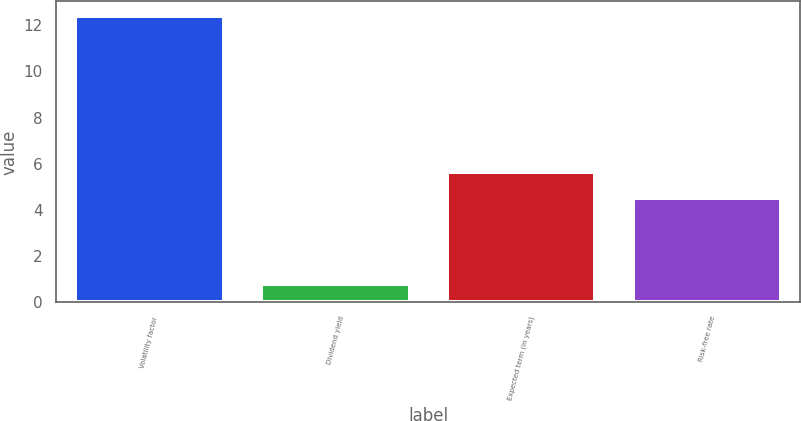Convert chart. <chart><loc_0><loc_0><loc_500><loc_500><bar_chart><fcel>Volatility factor<fcel>Dividend yield<fcel>Expected term (in years)<fcel>Risk-free rate<nl><fcel>12.4<fcel>0.8<fcel>5.66<fcel>4.5<nl></chart> 